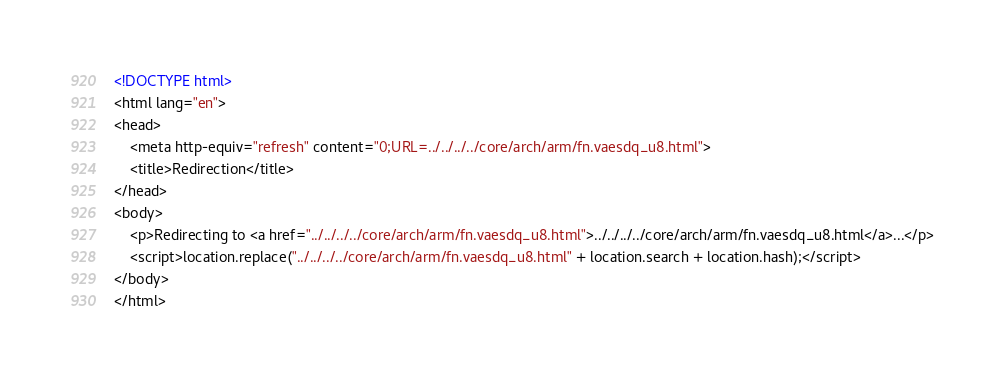Convert code to text. <code><loc_0><loc_0><loc_500><loc_500><_HTML_><!DOCTYPE html>
<html lang="en">
<head>
    <meta http-equiv="refresh" content="0;URL=../../../../core/arch/arm/fn.vaesdq_u8.html">
    <title>Redirection</title>
</head>
<body>
    <p>Redirecting to <a href="../../../../core/arch/arm/fn.vaesdq_u8.html">../../../../core/arch/arm/fn.vaesdq_u8.html</a>...</p>
    <script>location.replace("../../../../core/arch/arm/fn.vaesdq_u8.html" + location.search + location.hash);</script>
</body>
</html></code> 